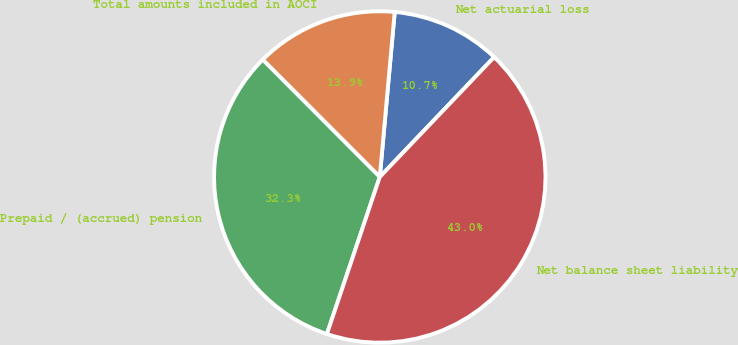<chart> <loc_0><loc_0><loc_500><loc_500><pie_chart><fcel>Net actuarial loss<fcel>Total amounts included in AOCI<fcel>Prepaid / (accrued) pension<fcel>Net balance sheet liability<nl><fcel>10.69%<fcel>13.92%<fcel>32.35%<fcel>43.04%<nl></chart> 